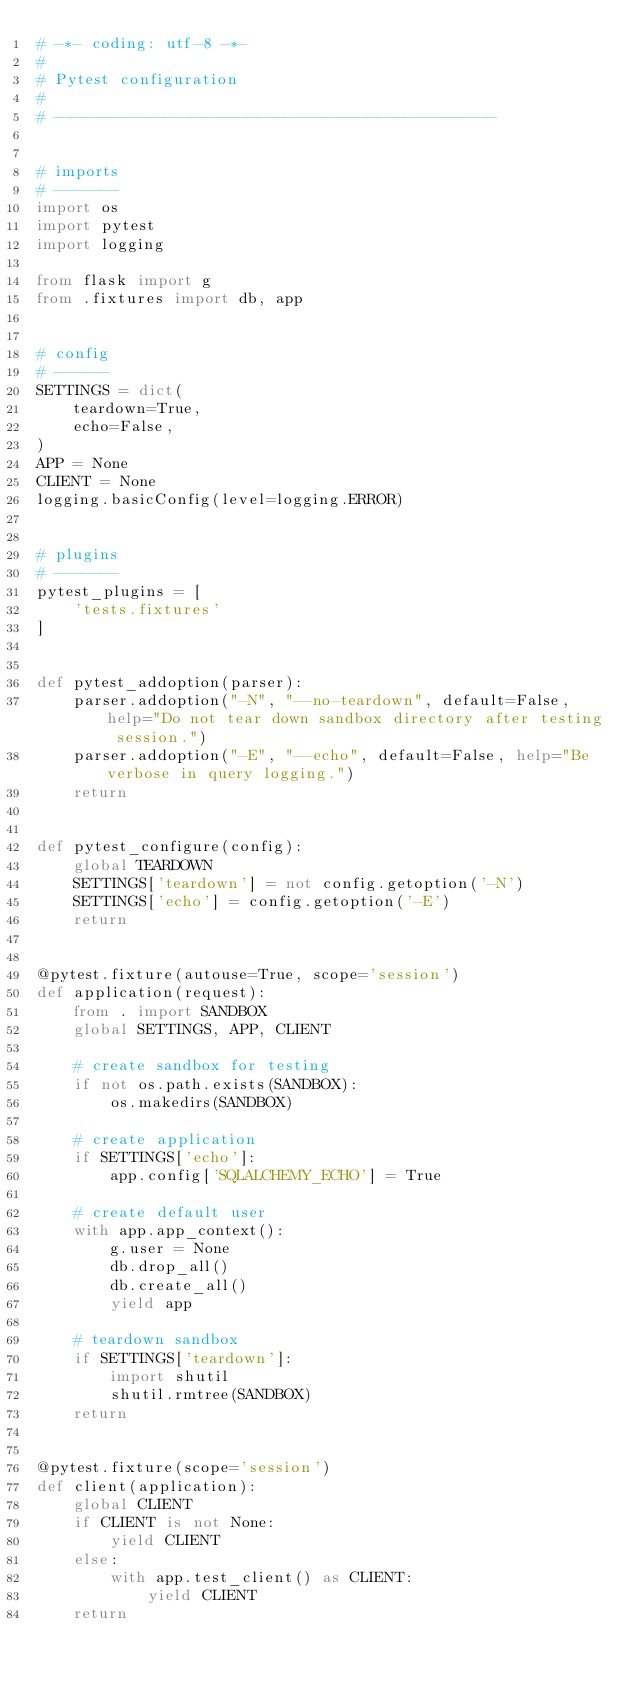Convert code to text. <code><loc_0><loc_0><loc_500><loc_500><_Python_># -*- coding: utf-8 -*-
#
# Pytest configuration
#
# ------------------------------------------------


# imports
# -------
import os
import pytest
import logging

from flask import g
from .fixtures import db, app


# config
# ------
SETTINGS = dict(
    teardown=True,
    echo=False,
)
APP = None
CLIENT = None
logging.basicConfig(level=logging.ERROR)


# plugins
# -------
pytest_plugins = [
    'tests.fixtures'
]


def pytest_addoption(parser):
    parser.addoption("-N", "--no-teardown", default=False, help="Do not tear down sandbox directory after testing session.")
    parser.addoption("-E", "--echo", default=False, help="Be verbose in query logging.")
    return


def pytest_configure(config):
    global TEARDOWN
    SETTINGS['teardown'] = not config.getoption('-N')
    SETTINGS['echo'] = config.getoption('-E')
    return


@pytest.fixture(autouse=True, scope='session')
def application(request):
    from . import SANDBOX
    global SETTINGS, APP, CLIENT

    # create sandbox for testing
    if not os.path.exists(SANDBOX):
        os.makedirs(SANDBOX)

    # create application
    if SETTINGS['echo']:
        app.config['SQLALCHEMY_ECHO'] = True

    # create default user
    with app.app_context():
        g.user = None
        db.drop_all()
        db.create_all()
        yield app

    # teardown sandbox
    if SETTINGS['teardown']:
        import shutil
        shutil.rmtree(SANDBOX)
    return


@pytest.fixture(scope='session')
def client(application):
    global CLIENT
    if CLIENT is not None:
        yield CLIENT
    else:
        with app.test_client() as CLIENT:
            yield CLIENT
    return
</code> 